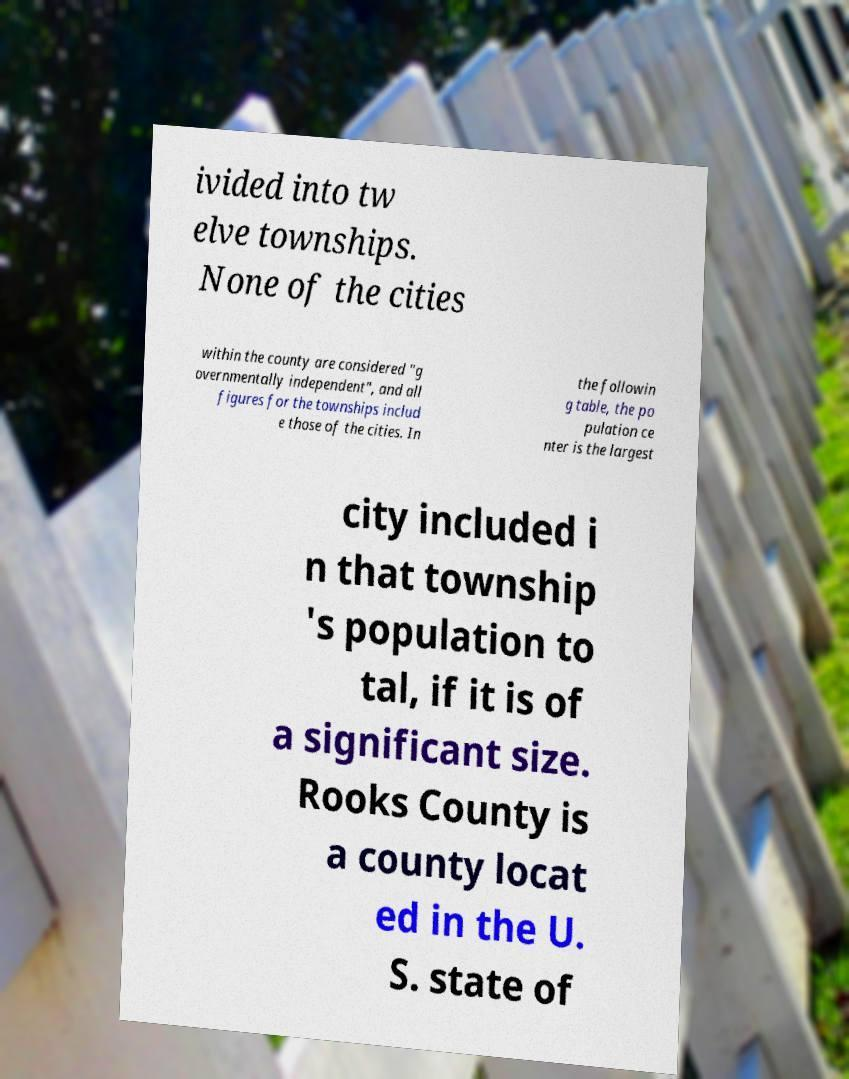Can you read and provide the text displayed in the image?This photo seems to have some interesting text. Can you extract and type it out for me? ivided into tw elve townships. None of the cities within the county are considered "g overnmentally independent", and all figures for the townships includ e those of the cities. In the followin g table, the po pulation ce nter is the largest city included i n that township 's population to tal, if it is of a significant size. Rooks County is a county locat ed in the U. S. state of 